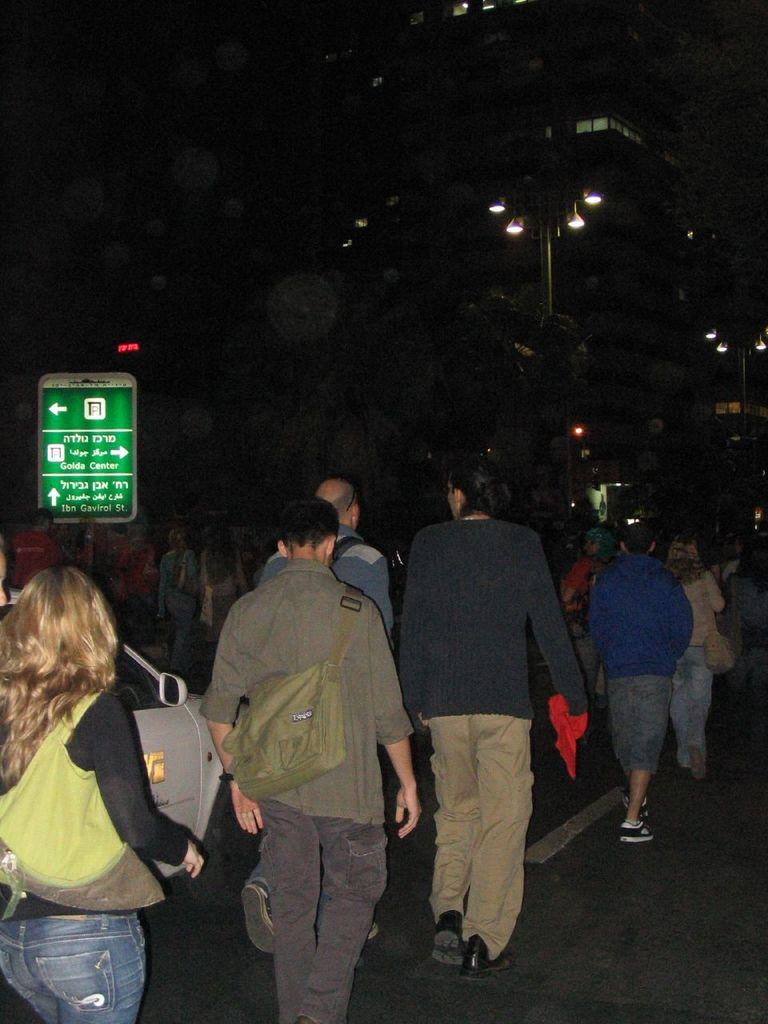What can be seen in the foreground of the image? There are people in the foreground of the image. What are the people wearing? The people are wearing bags. What are the people doing in the image? The people are walking on the road. What else is present in the image besides the people? There is a car, a board, lights, and buildings in the image. How would you describe the lighting in the image? The image is set in a dark environment. What type of calculator is being used by the guide in the image? There is no guide or calculator present in the image. What statement is being made by the people in the image? There is no statement being made by the people in the image; they are simply walking on the road. 